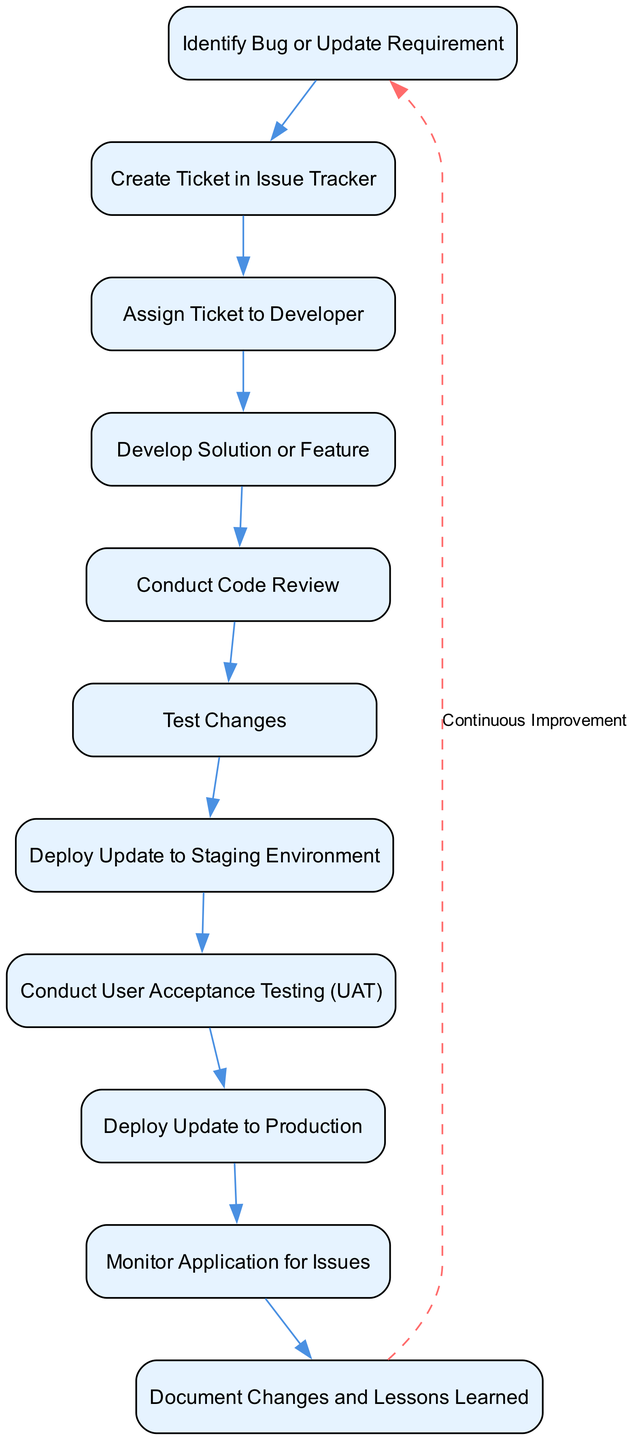What is the first step in the workflow? The diagram starts with the node labeled "Identify Bug or Update Requirement", which represents the initial step in the maintenance workflow.
Answer: Identify Bug or Update Requirement How many total nodes are present in the diagram? By counting each unique step represented by a node, we find there are eleven distinct nodes in the workflow.
Answer: 11 What is the last step before deploying the update to production? The last step before deployment is "Conduct User Acceptance Testing (UAT)", which precedes the final deployment action.
Answer: Conduct User Acceptance Testing (UAT) What is the relationship between "Test Changes" and "Deploy Update to Staging Environment"? "Test Changes" is a step that directly follows "Deploy Update to Staging Environment", forming a sequential relationship in the workflow.
Answer: Sequential relationship Which step indicates that documentation should occur? The step titled "Document Changes and Lessons Learned" clearly indicates when documentation should happen within the workflow.
Answer: Document Changes and Lessons Learned What feedback loop exists in the workflow? The diagram shows a continuous improvement loop that connects back from the last node to the first node, allowing for iterative updates.
Answer: Continuous Improvement How many steps are there between "Create Ticket in Issue Tracker" and "Deploy Update to Production"? The path from the "Create Ticket in Issue Tracker" to "Deploy Update to Production" involves four steps: Assign Ticket to Developer, Develop Solution or Feature, Conduct Code Review, and Test Changes.
Answer: 4 What is the purpose of the "Conduct Code Review" step? This step serves to ensure that the developed solution or feature maintains quality and adheres to coding standards, acting as a quality assurance measure in the workflow.
Answer: Quality assurance measure Which node is responsible for monitoring the application post-deployment? The node "Monitor Application for Issues" is designated for the activity of keeping an eye on the application for any potential issues that may arise after the update.
Answer: Monitor Application for Issues 